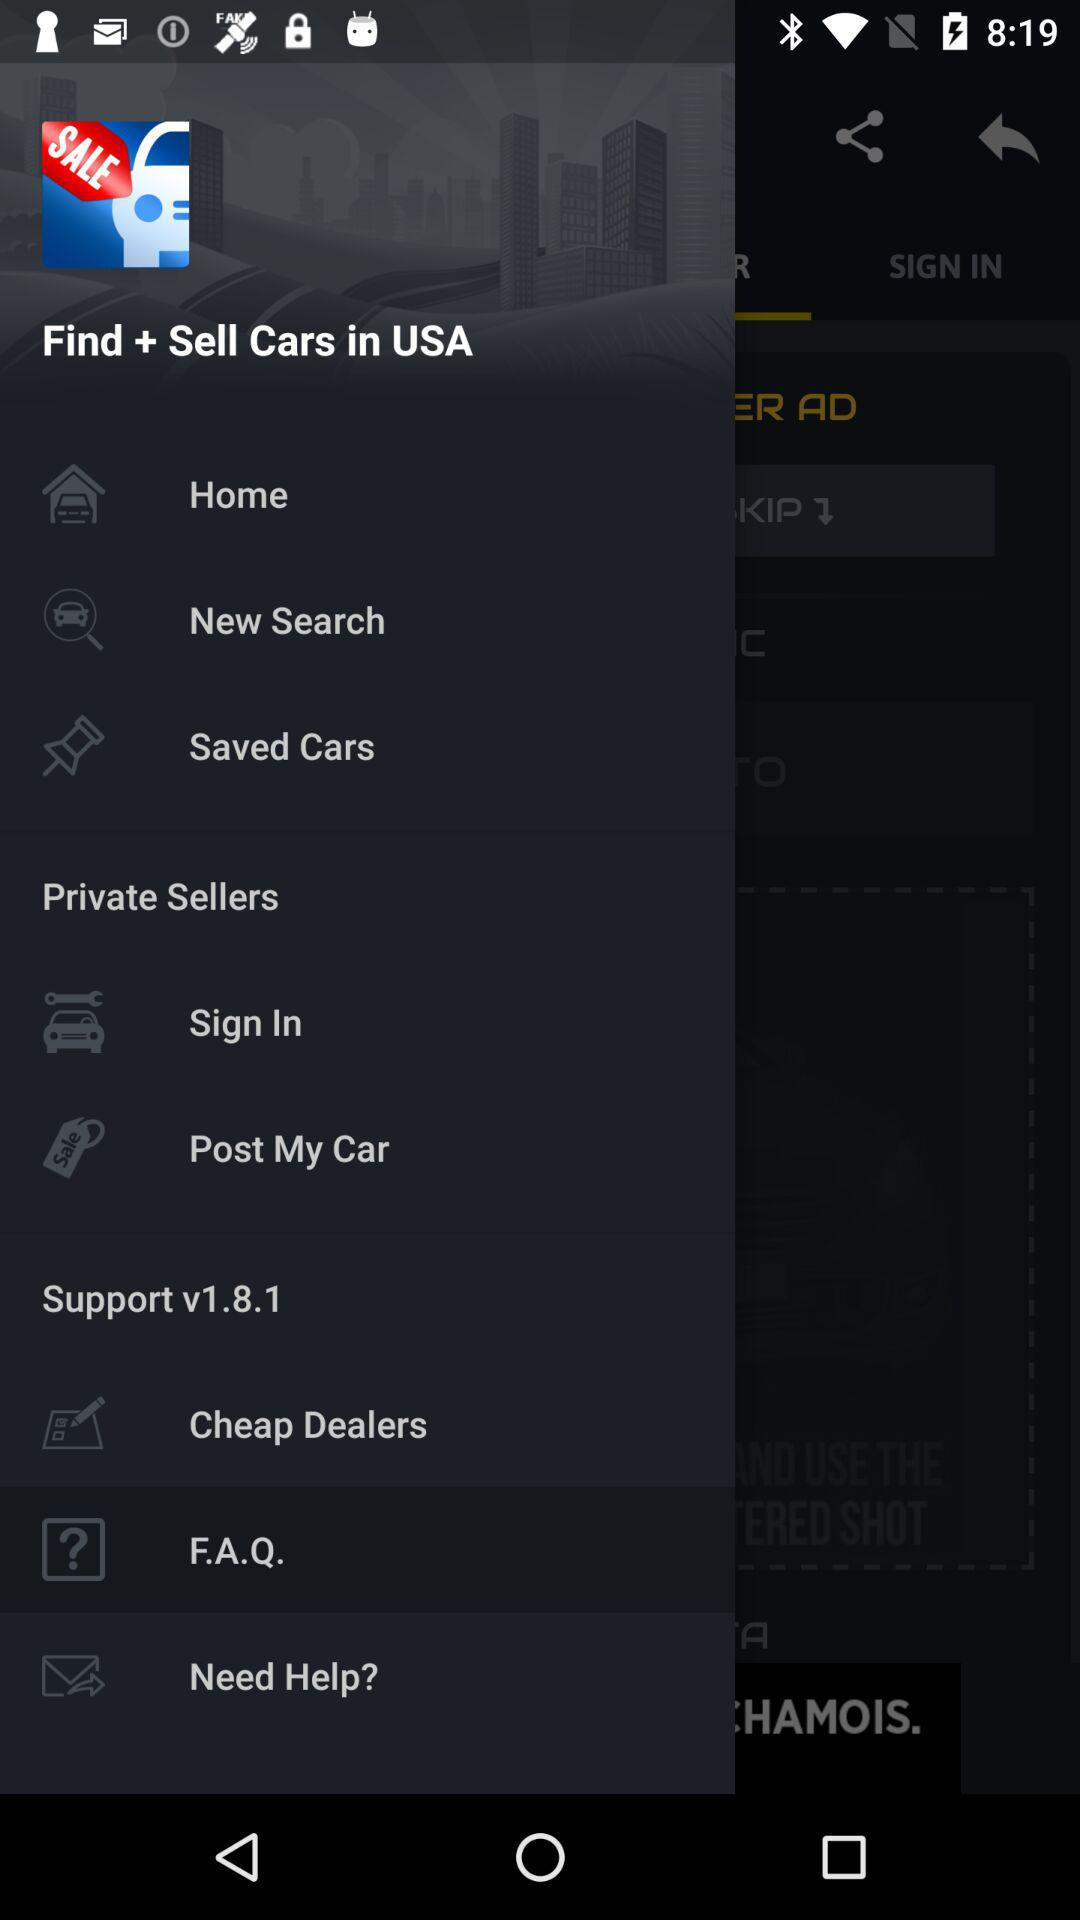What version is used? The used version is 1.8.1. 